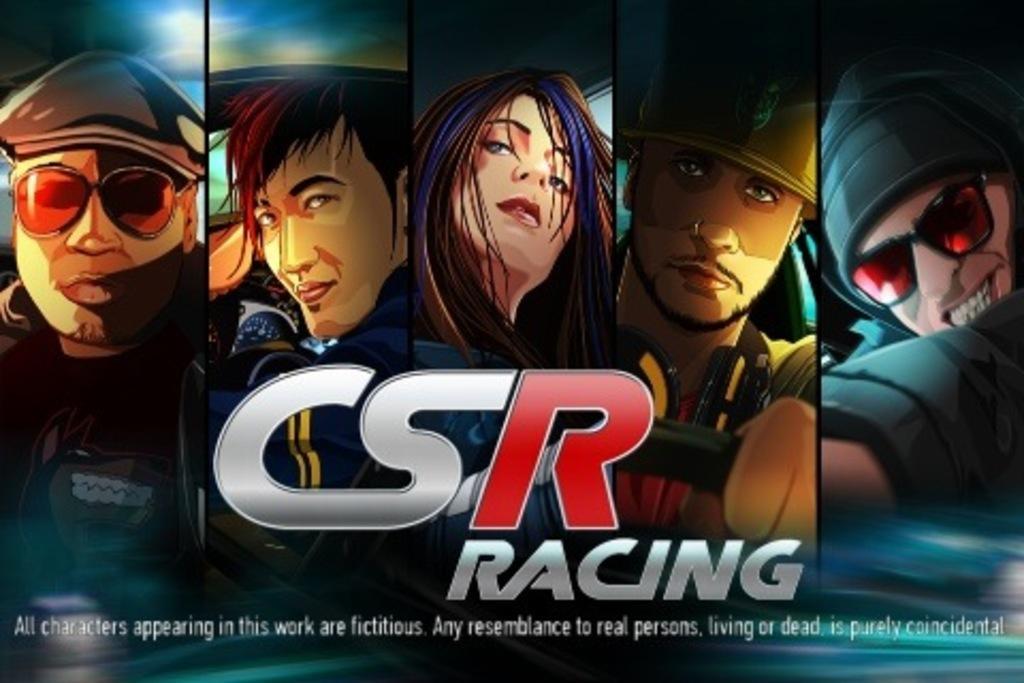Please provide a concise description of this image. In this image from left to right all these are cartoon character. 